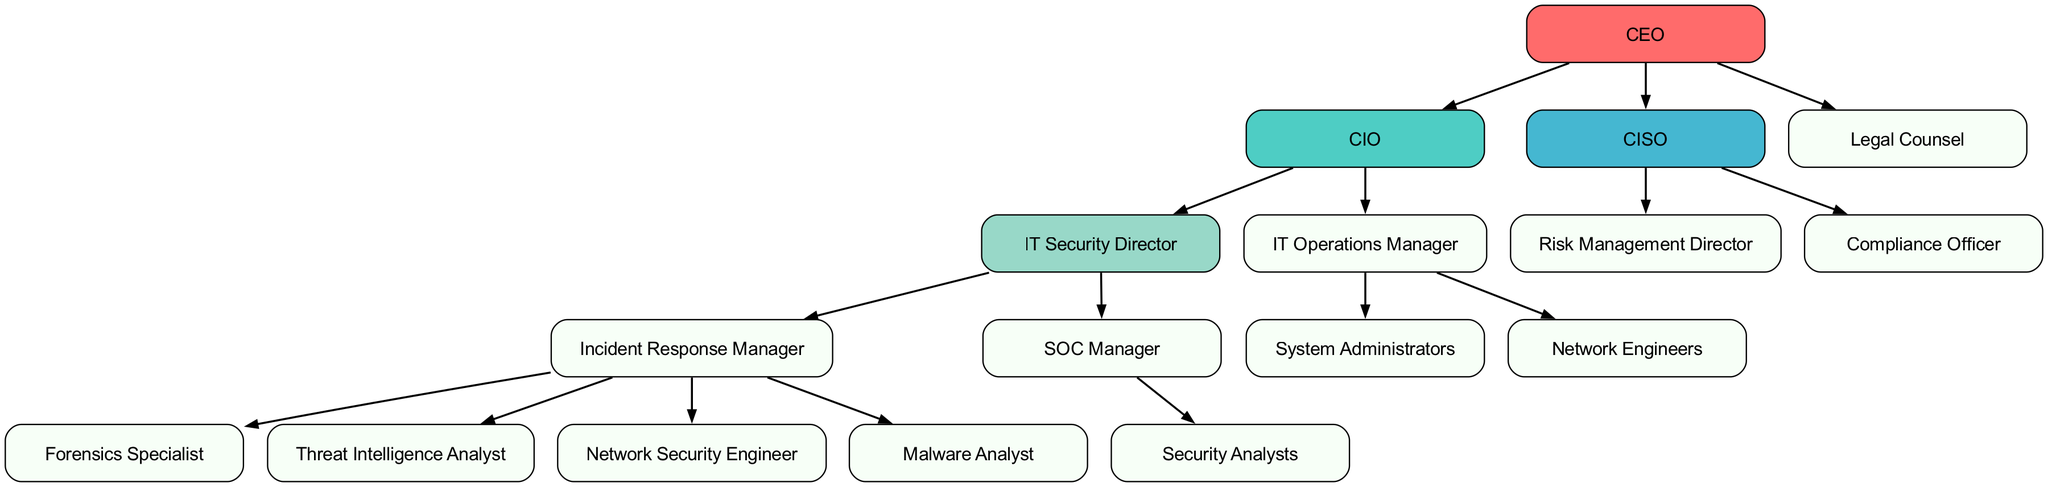What is the top node in the diagram? The top node, representing the highest level of the organization, is the "CEO." It sits at the apex of the hierarchy.
Answer: CEO How many roles report directly to the CIO? The CIO has three direct reports: the IT Security Director, the IT Operations Manager, and the Legal Counsel. Counting these roles gives a total of three.
Answer: 3 Which role is responsible for incident response? The role directly responsible for incident response is the "Incident Response Manager," who is positioned directly under the IT Security Director.
Answer: Incident Response Manager What is the relationship between the Legal Counsel and the CIO? The Legal Counsel is at the same level as the CIO, indicating that they are both direct reports to the CEO without a hierarchical relationship between them.
Answer: No direct relationship How many security analysts report to the SOC Manager? The SOC Manager oversees a team of Security Analysts; the diagram shows that there is no specified number placed, indicating an unspecified but plural count as a collective team.
Answer: Security Analysts Which role has a direct reporting line to the IT Security Director? The "Incident Response Manager" and "SOC Manager" both report directly to the IT Security Director. This indicates that the structure under IT Security Director has two distinct branches.
Answer: Incident Response Manager, SOC Manager What is the lowest role in the hierarchy? The lowest roles in the hierarchy that report under other roles are the Forensics Specialist, Threat Intelligence Analyst, Network Security Engineer, Malware Analyst, and Security Analysts. Each of these roles does not have any subordinates, making them the terminal roles.
Answer: Forensics Specialist, Threat Intelligence Analyst, Network Security Engineer, Malware Analyst, Security Analysts Which role oversees both compliance and risk management? The CISO oversees risk management and compliance through two specific positions: the Risk Management Director and the Compliance Officer, indicating that this role has a dual focus area linked to compliance and risk.
Answer: CISO What color represents the IT Security Director in the diagram? The IT Security Director is represented in a color-coded scheme as "#98D8C8," which is a specific hex color showing its distinctiveness in the hierarchy relative to other roles.
Answer: #98D8C8 How many distinct sub-branches are pictured under the CIO? There are two distinct sub-branches under the CIO: one for the IT Security Director and one for the IT Operations Manager, which reflects the bifurcated structure beneath the CIO.
Answer: 2 